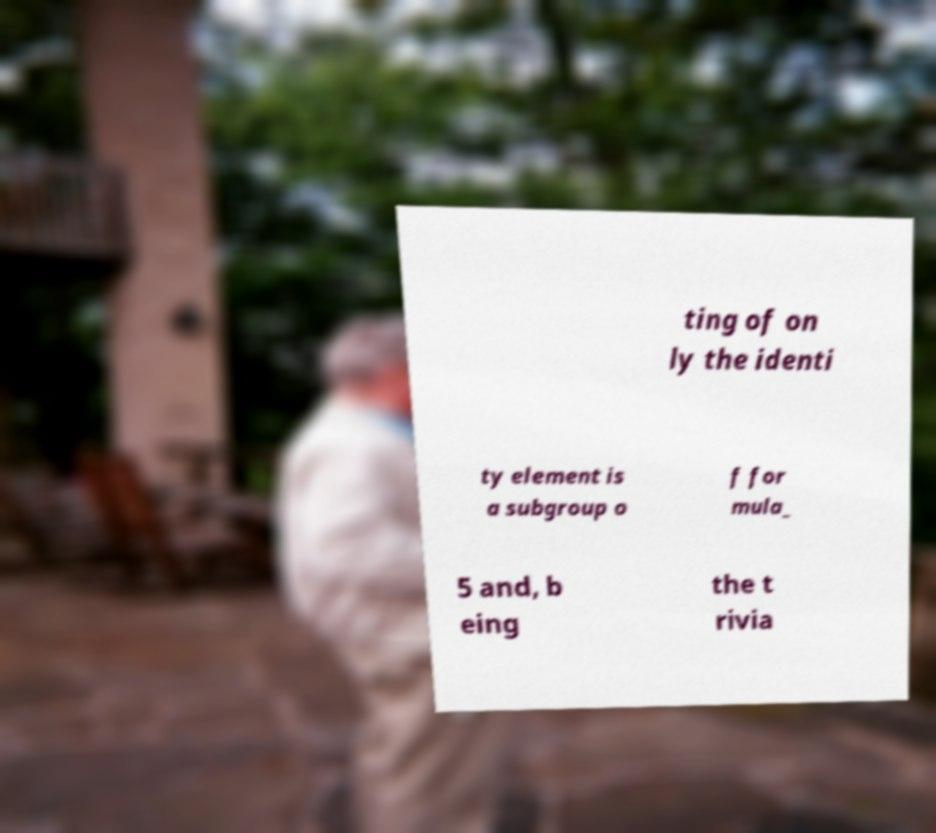I need the written content from this picture converted into text. Can you do that? ting of on ly the identi ty element is a subgroup o f for mula_ 5 and, b eing the t rivia 